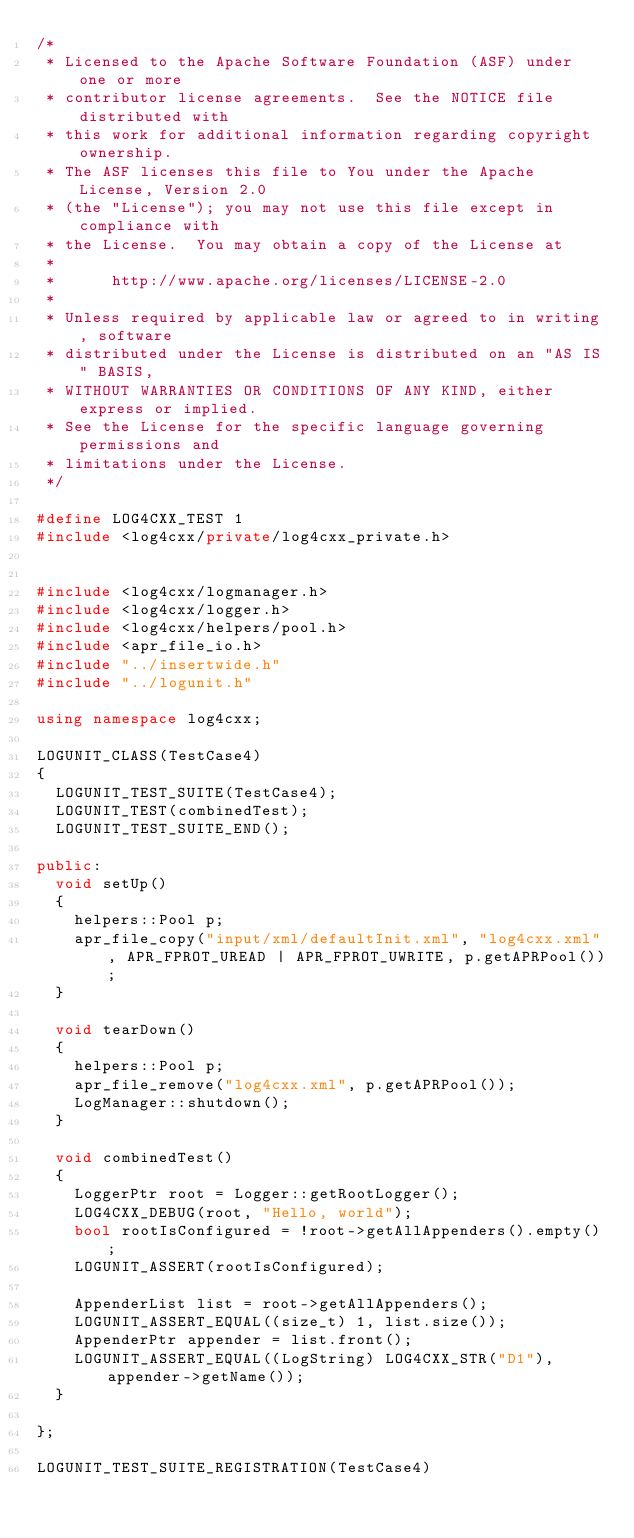Convert code to text. <code><loc_0><loc_0><loc_500><loc_500><_C++_>/*
 * Licensed to the Apache Software Foundation (ASF) under one or more
 * contributor license agreements.  See the NOTICE file distributed with
 * this work for additional information regarding copyright ownership.
 * The ASF licenses this file to You under the Apache License, Version 2.0
 * (the "License"); you may not use this file except in compliance with
 * the License.  You may obtain a copy of the License at
 *
 *      http://www.apache.org/licenses/LICENSE-2.0
 *
 * Unless required by applicable law or agreed to in writing, software
 * distributed under the License is distributed on an "AS IS" BASIS,
 * WITHOUT WARRANTIES OR CONDITIONS OF ANY KIND, either express or implied.
 * See the License for the specific language governing permissions and
 * limitations under the License.
 */

#define LOG4CXX_TEST 1
#include <log4cxx/private/log4cxx_private.h>


#include <log4cxx/logmanager.h>
#include <log4cxx/logger.h>
#include <log4cxx/helpers/pool.h>
#include <apr_file_io.h>
#include "../insertwide.h"
#include "../logunit.h"

using namespace log4cxx;

LOGUNIT_CLASS(TestCase4)
{
	LOGUNIT_TEST_SUITE(TestCase4);
	LOGUNIT_TEST(combinedTest);
	LOGUNIT_TEST_SUITE_END();

public:
	void setUp()
	{
		helpers::Pool p;
		apr_file_copy("input/xml/defaultInit.xml", "log4cxx.xml", APR_FPROT_UREAD | APR_FPROT_UWRITE, p.getAPRPool());
	}

	void tearDown()
	{
		helpers::Pool p;
		apr_file_remove("log4cxx.xml", p.getAPRPool());
		LogManager::shutdown();
	}

	void combinedTest()
	{
		LoggerPtr root = Logger::getRootLogger();
		LOG4CXX_DEBUG(root, "Hello, world");
		bool rootIsConfigured = !root->getAllAppenders().empty();
		LOGUNIT_ASSERT(rootIsConfigured);

		AppenderList list = root->getAllAppenders();
		LOGUNIT_ASSERT_EQUAL((size_t) 1, list.size());
		AppenderPtr appender = list.front();
		LOGUNIT_ASSERT_EQUAL((LogString) LOG4CXX_STR("D1"), appender->getName());
	}

};

LOGUNIT_TEST_SUITE_REGISTRATION(TestCase4)

</code> 